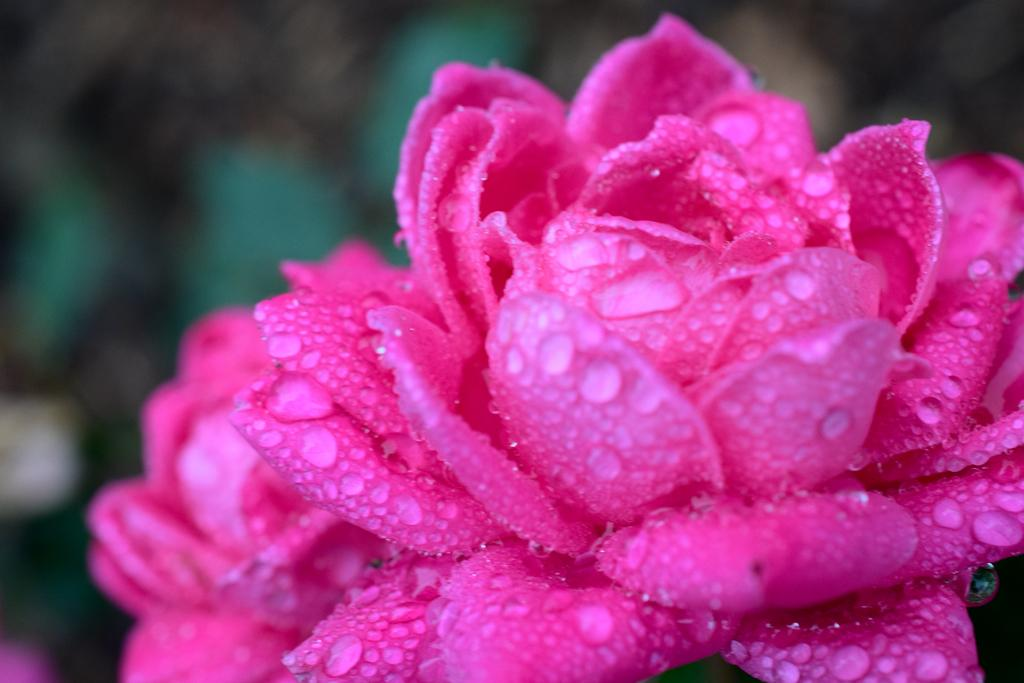What is the condition of the flowers in the image? There are water drops on the flowers in the image. Can you describe the background of the image? The background of the image is blurry. What type of kettle can be seen in the image? There is no kettle present in the image. How many bites have been taken out of the flowers in the image? The flowers in the image are not food, so there are no bites taken out of them. 